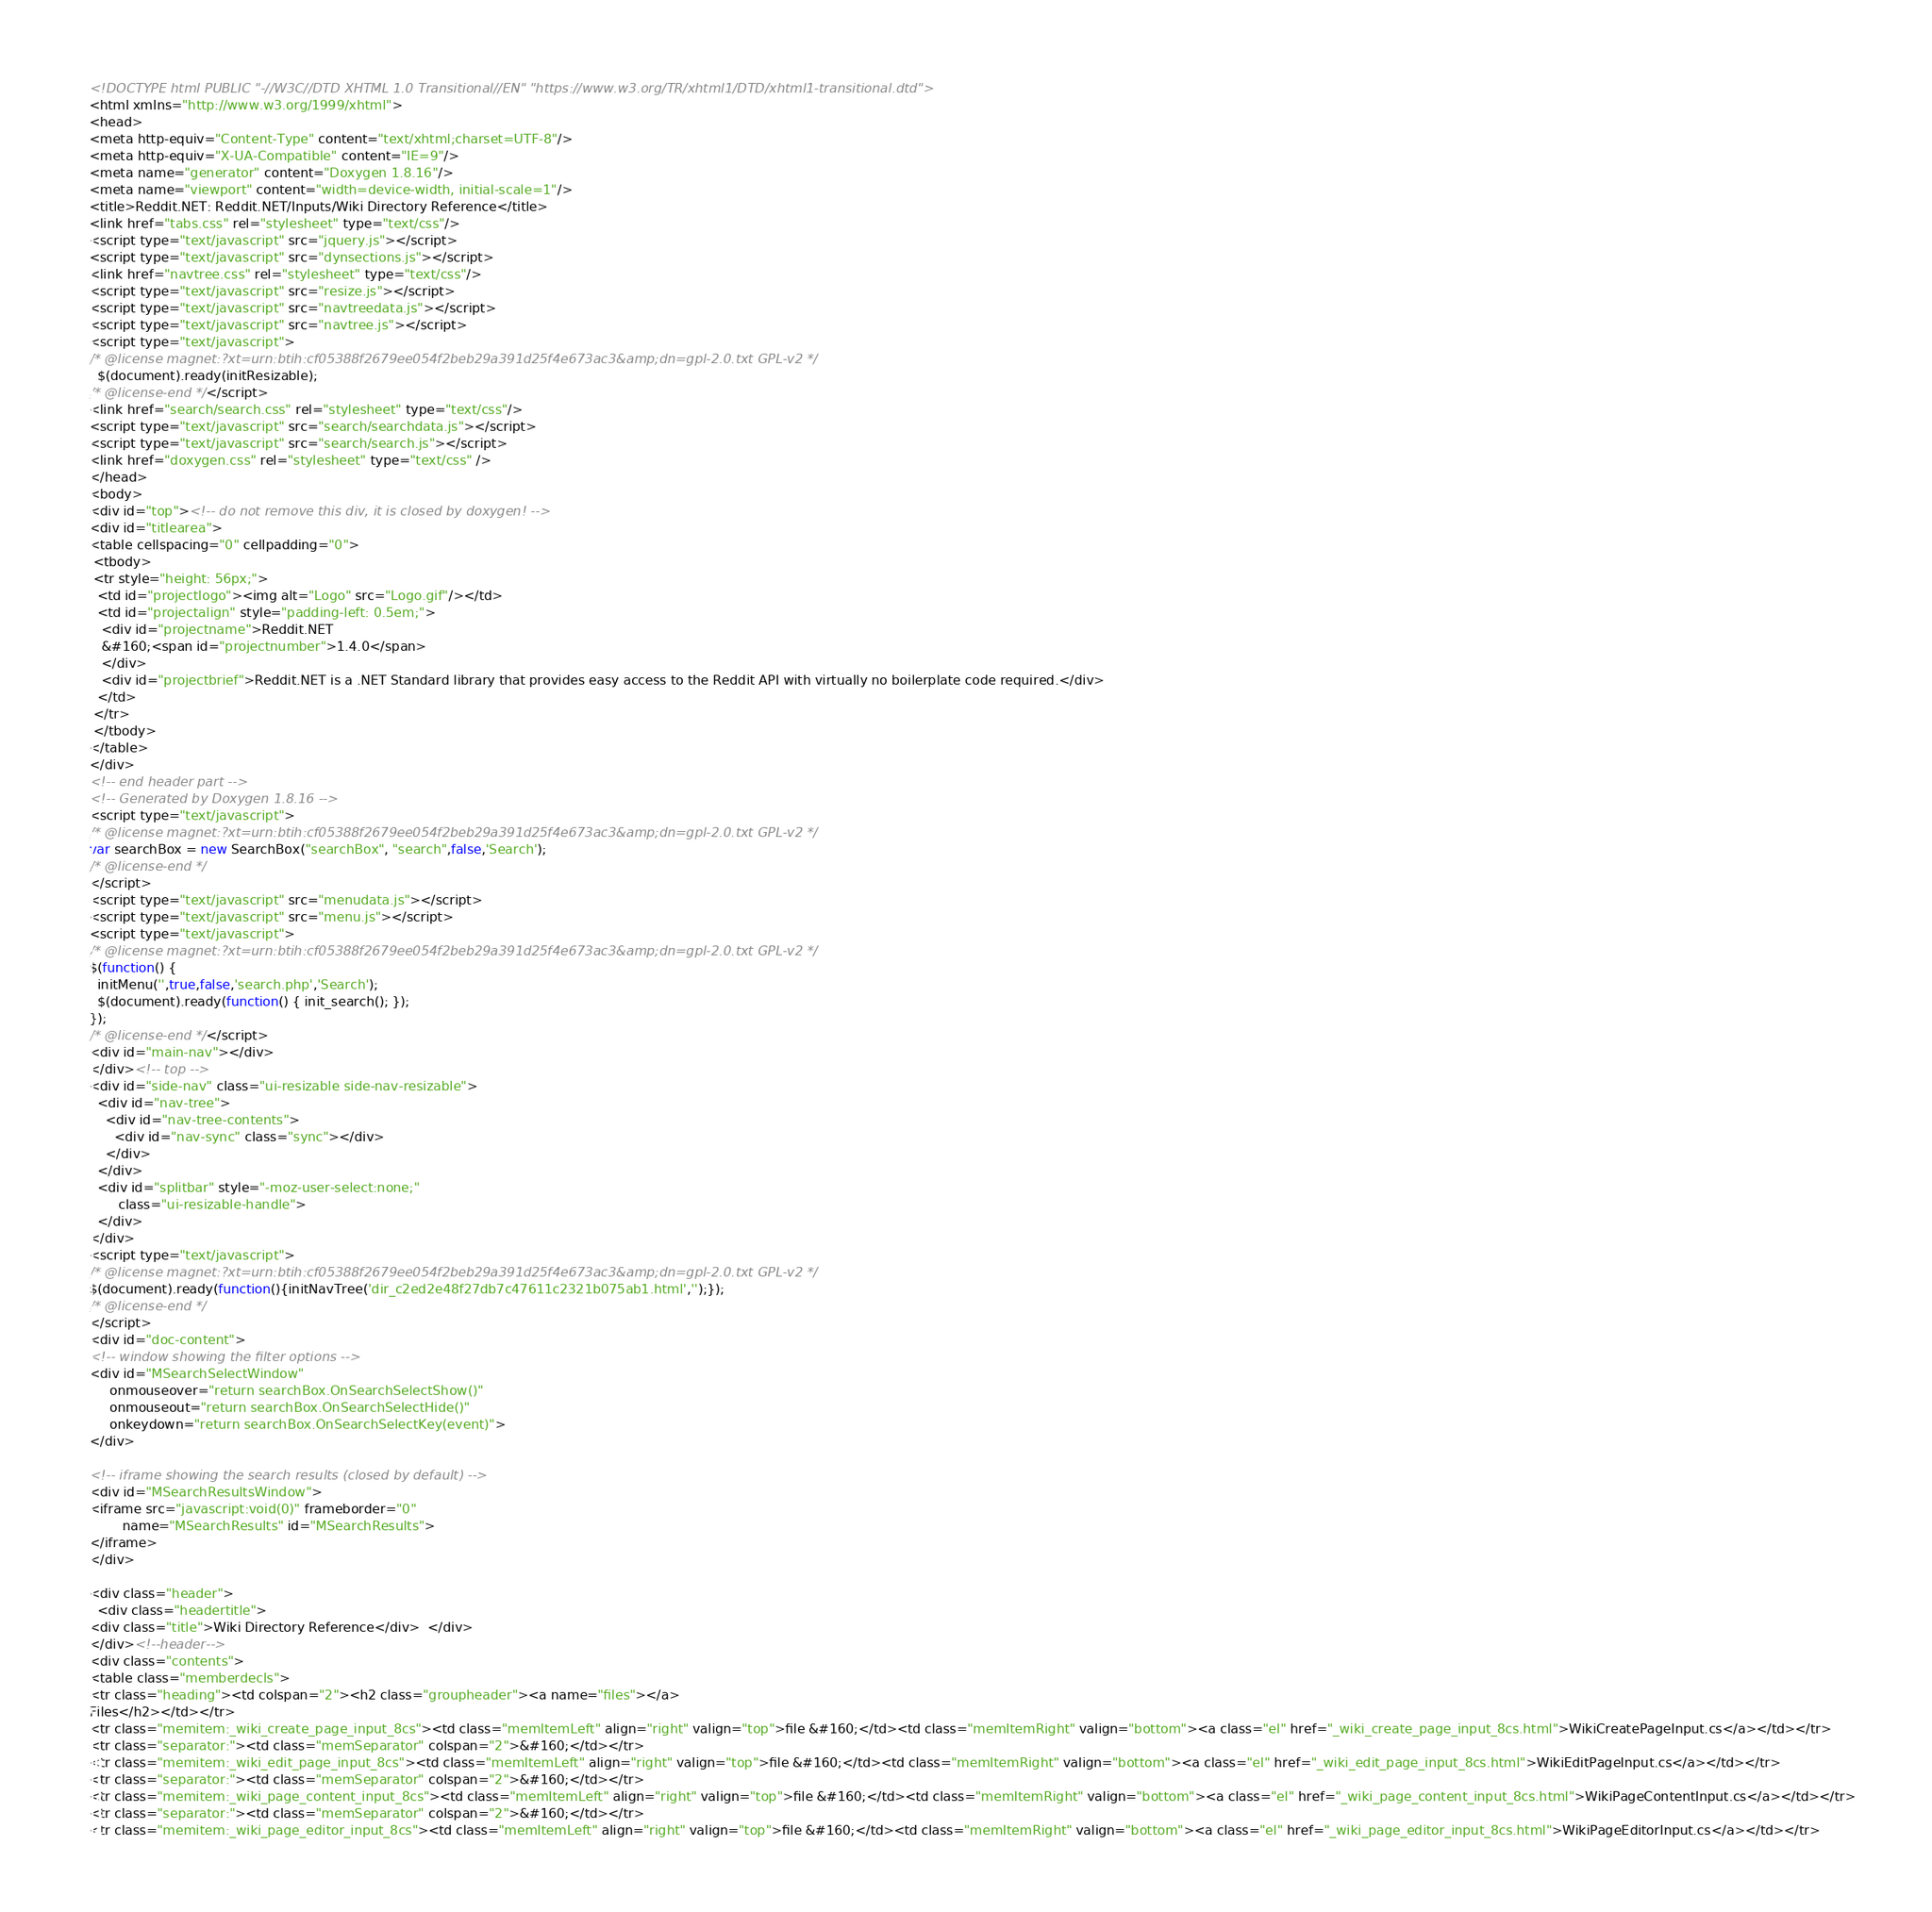Convert code to text. <code><loc_0><loc_0><loc_500><loc_500><_HTML_><!DOCTYPE html PUBLIC "-//W3C//DTD XHTML 1.0 Transitional//EN" "https://www.w3.org/TR/xhtml1/DTD/xhtml1-transitional.dtd">
<html xmlns="http://www.w3.org/1999/xhtml">
<head>
<meta http-equiv="Content-Type" content="text/xhtml;charset=UTF-8"/>
<meta http-equiv="X-UA-Compatible" content="IE=9"/>
<meta name="generator" content="Doxygen 1.8.16"/>
<meta name="viewport" content="width=device-width, initial-scale=1"/>
<title>Reddit.NET: Reddit.NET/Inputs/Wiki Directory Reference</title>
<link href="tabs.css" rel="stylesheet" type="text/css"/>
<script type="text/javascript" src="jquery.js"></script>
<script type="text/javascript" src="dynsections.js"></script>
<link href="navtree.css" rel="stylesheet" type="text/css"/>
<script type="text/javascript" src="resize.js"></script>
<script type="text/javascript" src="navtreedata.js"></script>
<script type="text/javascript" src="navtree.js"></script>
<script type="text/javascript">
/* @license magnet:?xt=urn:btih:cf05388f2679ee054f2beb29a391d25f4e673ac3&amp;dn=gpl-2.0.txt GPL-v2 */
  $(document).ready(initResizable);
/* @license-end */</script>
<link href="search/search.css" rel="stylesheet" type="text/css"/>
<script type="text/javascript" src="search/searchdata.js"></script>
<script type="text/javascript" src="search/search.js"></script>
<link href="doxygen.css" rel="stylesheet" type="text/css" />
</head>
<body>
<div id="top"><!-- do not remove this div, it is closed by doxygen! -->
<div id="titlearea">
<table cellspacing="0" cellpadding="0">
 <tbody>
 <tr style="height: 56px;">
  <td id="projectlogo"><img alt="Logo" src="Logo.gif"/></td>
  <td id="projectalign" style="padding-left: 0.5em;">
   <div id="projectname">Reddit.NET
   &#160;<span id="projectnumber">1.4.0</span>
   </div>
   <div id="projectbrief">Reddit.NET is a .NET Standard library that provides easy access to the Reddit API with virtually no boilerplate code required.</div>
  </td>
 </tr>
 </tbody>
</table>
</div>
<!-- end header part -->
<!-- Generated by Doxygen 1.8.16 -->
<script type="text/javascript">
/* @license magnet:?xt=urn:btih:cf05388f2679ee054f2beb29a391d25f4e673ac3&amp;dn=gpl-2.0.txt GPL-v2 */
var searchBox = new SearchBox("searchBox", "search",false,'Search');
/* @license-end */
</script>
<script type="text/javascript" src="menudata.js"></script>
<script type="text/javascript" src="menu.js"></script>
<script type="text/javascript">
/* @license magnet:?xt=urn:btih:cf05388f2679ee054f2beb29a391d25f4e673ac3&amp;dn=gpl-2.0.txt GPL-v2 */
$(function() {
  initMenu('',true,false,'search.php','Search');
  $(document).ready(function() { init_search(); });
});
/* @license-end */</script>
<div id="main-nav"></div>
</div><!-- top -->
<div id="side-nav" class="ui-resizable side-nav-resizable">
  <div id="nav-tree">
    <div id="nav-tree-contents">
      <div id="nav-sync" class="sync"></div>
    </div>
  </div>
  <div id="splitbar" style="-moz-user-select:none;" 
       class="ui-resizable-handle">
  </div>
</div>
<script type="text/javascript">
/* @license magnet:?xt=urn:btih:cf05388f2679ee054f2beb29a391d25f4e673ac3&amp;dn=gpl-2.0.txt GPL-v2 */
$(document).ready(function(){initNavTree('dir_c2ed2e48f27db7c47611c2321b075ab1.html','');});
/* @license-end */
</script>
<div id="doc-content">
<!-- window showing the filter options -->
<div id="MSearchSelectWindow"
     onmouseover="return searchBox.OnSearchSelectShow()"
     onmouseout="return searchBox.OnSearchSelectHide()"
     onkeydown="return searchBox.OnSearchSelectKey(event)">
</div>

<!-- iframe showing the search results (closed by default) -->
<div id="MSearchResultsWindow">
<iframe src="javascript:void(0)" frameborder="0" 
        name="MSearchResults" id="MSearchResults">
</iframe>
</div>

<div class="header">
  <div class="headertitle">
<div class="title">Wiki Directory Reference</div>  </div>
</div><!--header-->
<div class="contents">
<table class="memberdecls">
<tr class="heading"><td colspan="2"><h2 class="groupheader"><a name="files"></a>
Files</h2></td></tr>
<tr class="memitem:_wiki_create_page_input_8cs"><td class="memItemLeft" align="right" valign="top">file &#160;</td><td class="memItemRight" valign="bottom"><a class="el" href="_wiki_create_page_input_8cs.html">WikiCreatePageInput.cs</a></td></tr>
<tr class="separator:"><td class="memSeparator" colspan="2">&#160;</td></tr>
<tr class="memitem:_wiki_edit_page_input_8cs"><td class="memItemLeft" align="right" valign="top">file &#160;</td><td class="memItemRight" valign="bottom"><a class="el" href="_wiki_edit_page_input_8cs.html">WikiEditPageInput.cs</a></td></tr>
<tr class="separator:"><td class="memSeparator" colspan="2">&#160;</td></tr>
<tr class="memitem:_wiki_page_content_input_8cs"><td class="memItemLeft" align="right" valign="top">file &#160;</td><td class="memItemRight" valign="bottom"><a class="el" href="_wiki_page_content_input_8cs.html">WikiPageContentInput.cs</a></td></tr>
<tr class="separator:"><td class="memSeparator" colspan="2">&#160;</td></tr>
<tr class="memitem:_wiki_page_editor_input_8cs"><td class="memItemLeft" align="right" valign="top">file &#160;</td><td class="memItemRight" valign="bottom"><a class="el" href="_wiki_page_editor_input_8cs.html">WikiPageEditorInput.cs</a></td></tr></code> 